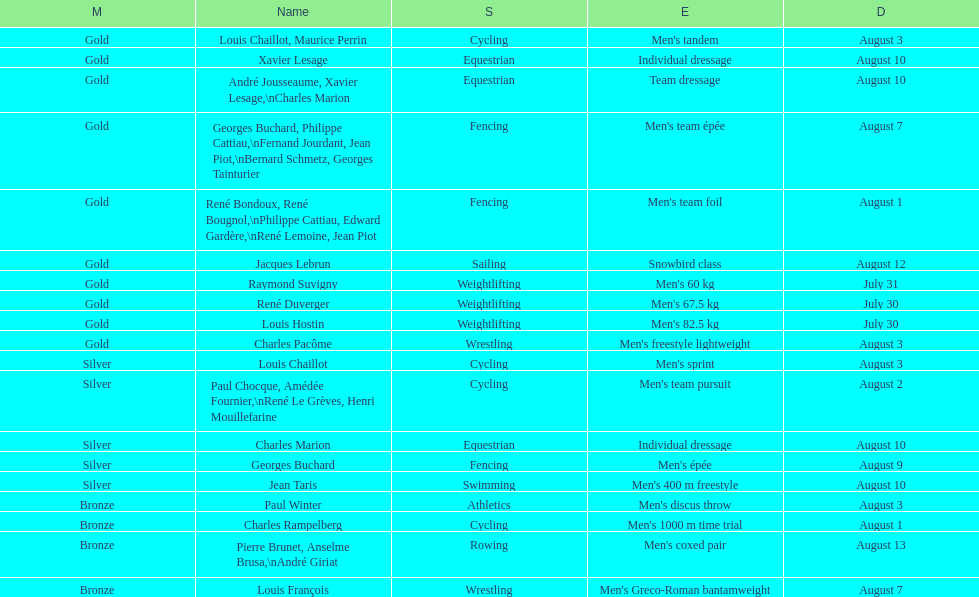Right before team dressage, what event is listed? Individual dressage. 